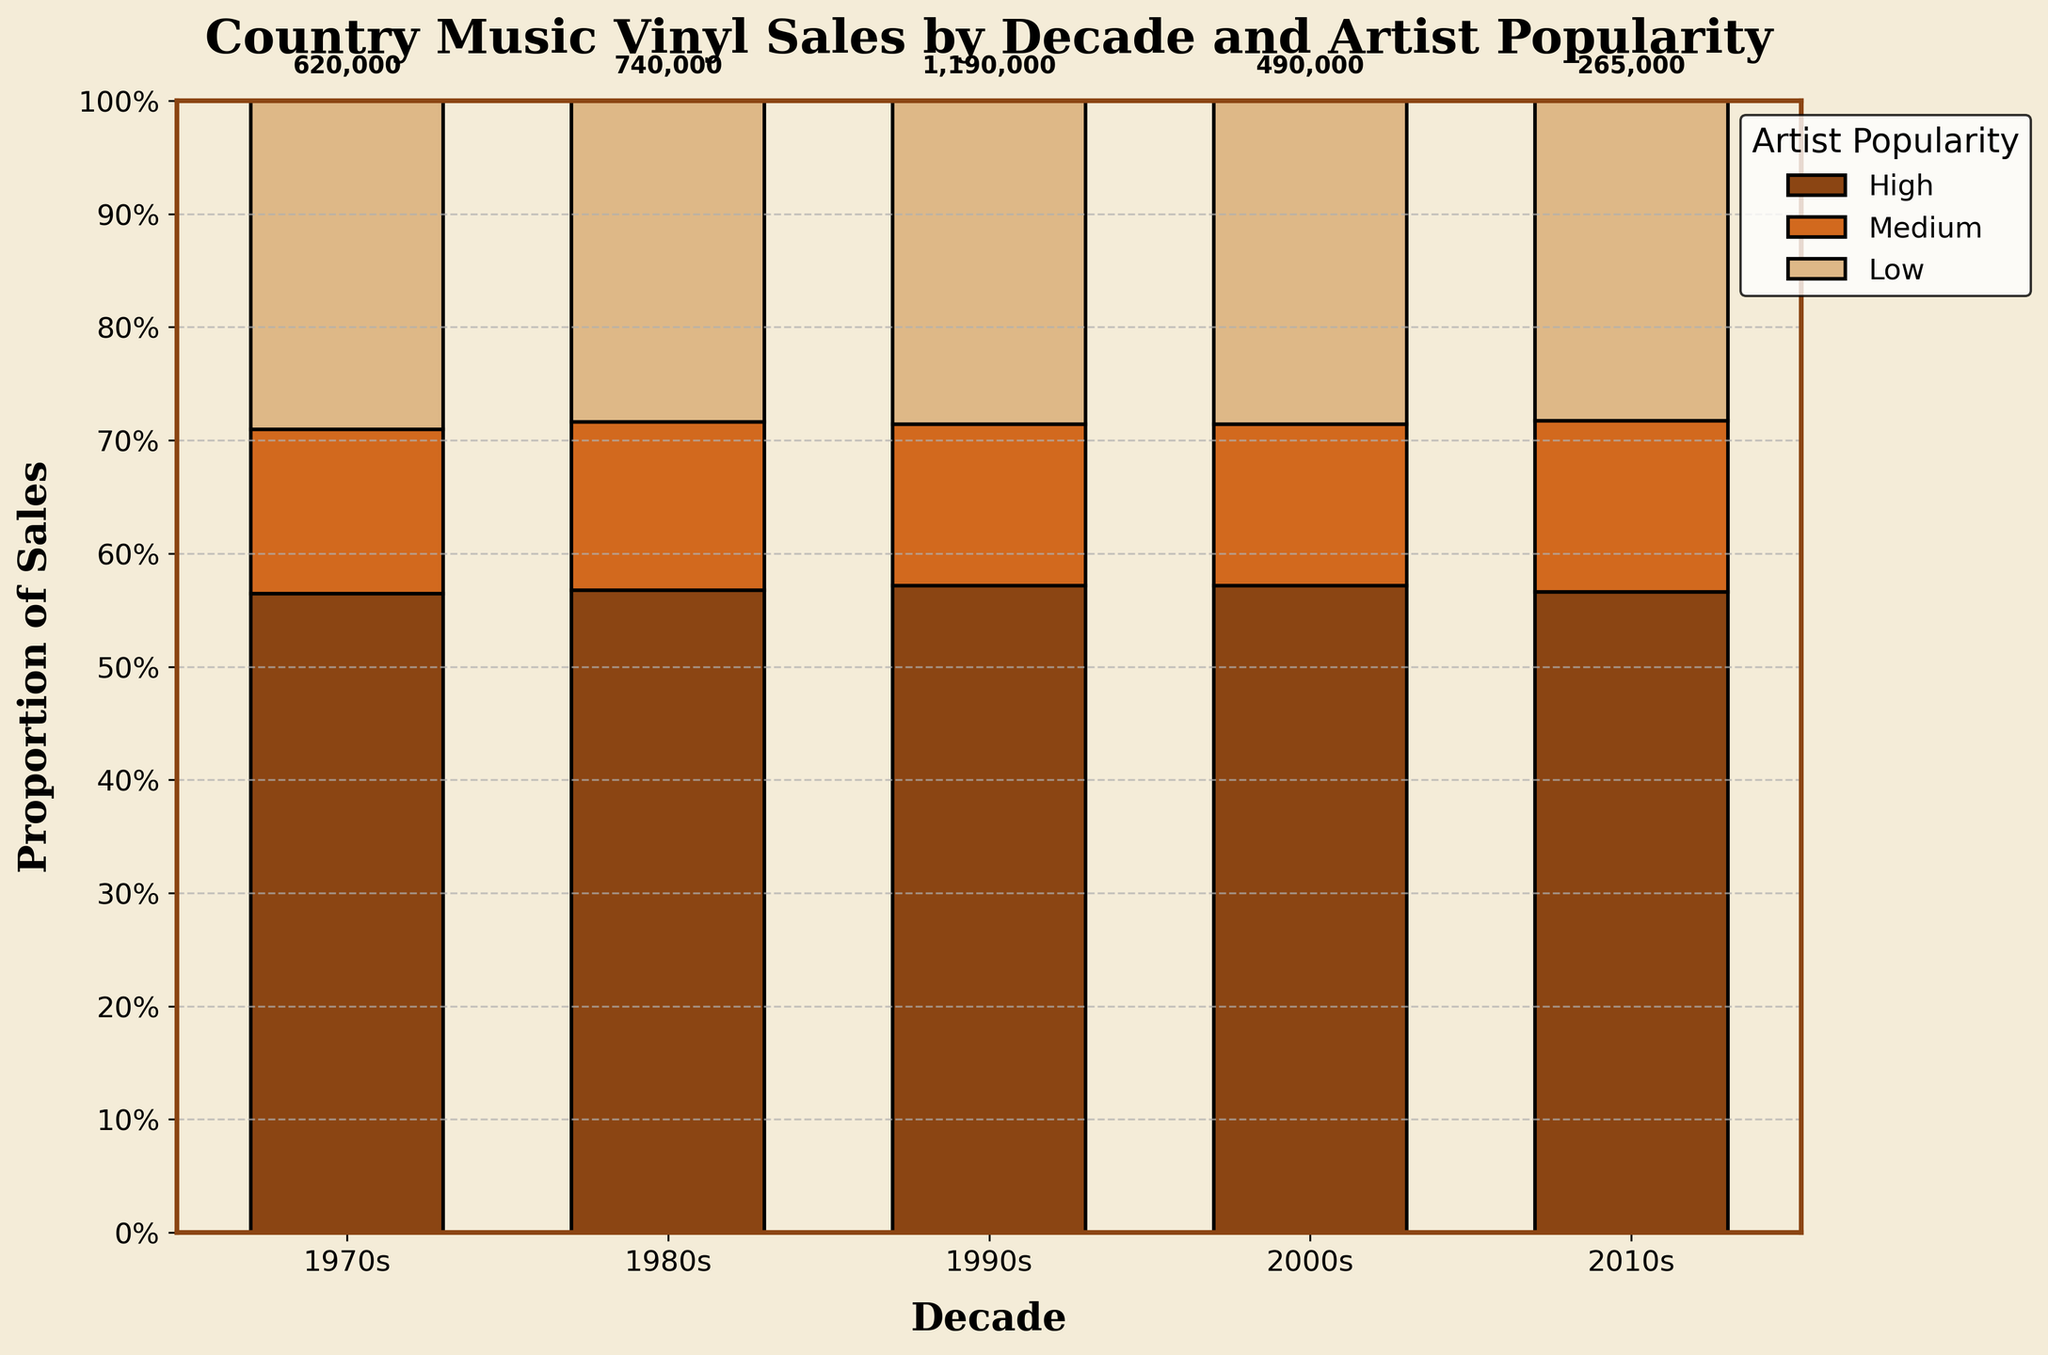What is the title of the plot? The title is located at the top of the figure. It reads "Country Music Vinyl Sales by Decade and Artist Popularity." This title shows the main focus of the plot is the sales distribution across different decades and popularity levels.
Answer: Country Music Vinyl Sales by Decade and Artist Popularity Which decade has the highest total vinyl sales? The highest total vinyl sales can be identified by the largest value displayed at the top of the bars for each decade. The 1990s show a value of 1,190,000, which is the highest among the other decades.
Answer: 1990s How is the sales distribution from high popularity artists in the 2000s compared to medium popularity artists in the same decade? Look at the segment heights in the 2000s bar corresponding to "High" and "Medium" popularity. The "High" segment covers about twice as much area as the "Medium" segment, implying that "High" sales are significantly higher.
Answer: Higher What proportion of sales in the 1970s is from low popularity artists? Find the "Low" section in the 1970s bar. It occupies about one-fourth of the bar's height, indicating approximately 25% of the total sales in the 1970s are from low popularity artists.
Answer: 25% Which decade has the smallest contribution from low popularity artists? Locate the smallest segment labeled "Low" across all decades. The 2010s have the smallest "Low" segment.
Answer: 2010s Compare the proportion of high popularity sales in the 1980s with the 1990s. Observe the "High" segments within the 1980s and 1990s bars. The "High" section in the 1990s is relatively larger, indicating the proportion of high popularity sales is greater in the 1990s compared to the 1980s.
Answer: Greater in the 1990s What is the combined sales of medium popularity artists across all decades? Add the sales numbers for medium popularity artists from each decade: 180,000 (1970s) + 210,000 (1980s) + 340,000 (1990s) + 140,000 (2000s) + 75,000 (2010s). The total is: 180,000 + 210,000 + 340,000 + 140,000 + 75,000 = 945,000.
Answer: 945,000 How has the proportion of high popularity artist sales changed from the 1970s to the 2010s? Examine the "High" segments for the 1970s and 2010s. In the 1970s, high popularity sales dominate a significant portion, about half. By the 2010s, the "High" section is much smaller, occupying roughly a fifth of the height. This shows a decrease in the proportion over time.
Answer: Decreased What is the total vinyl sales for low popularity artists in the 1980s and 2010s combined? Sum the sales for low popularity artists in these two decades: 110,000 (1980s) + 40,000 (2010s). The total is 110,000 + 40,000 = 150,000.
Answer: 150,000 